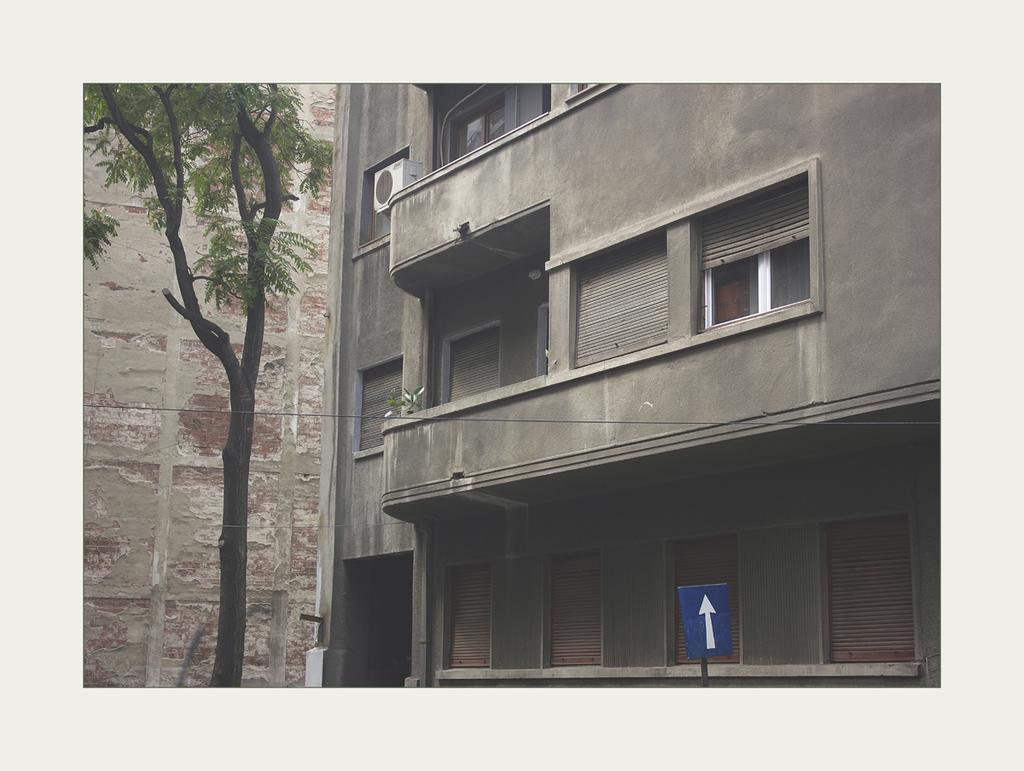What type of structure is present in the image? There is a building in the image. What feature can be seen on the building? The building has windows. What natural element is visible in the image? There is a tree in the image. What is the color of the board in the image? There is a blue color board in the image. What can be seen in the background of the image? There is a wall visible in the background of the image. What type of theory is being discussed by the goldfish in the image? There are no goldfish present in the image, so no theory can be discussed. What rhythm is being played by the instruments in the image? There are no instruments or music present in the image, so no rhythm can be identified. 